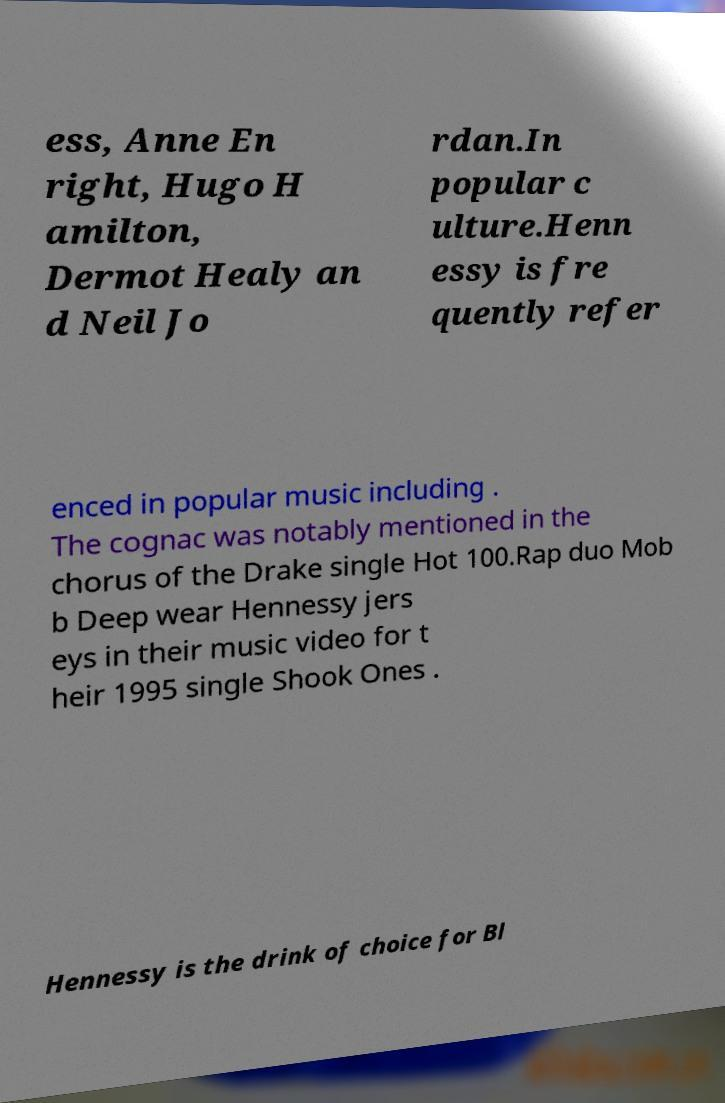Please read and relay the text visible in this image. What does it say? ess, Anne En right, Hugo H amilton, Dermot Healy an d Neil Jo rdan.In popular c ulture.Henn essy is fre quently refer enced in popular music including . The cognac was notably mentioned in the chorus of the Drake single Hot 100.Rap duo Mob b Deep wear Hennessy jers eys in their music video for t heir 1995 single Shook Ones . Hennessy is the drink of choice for Bl 